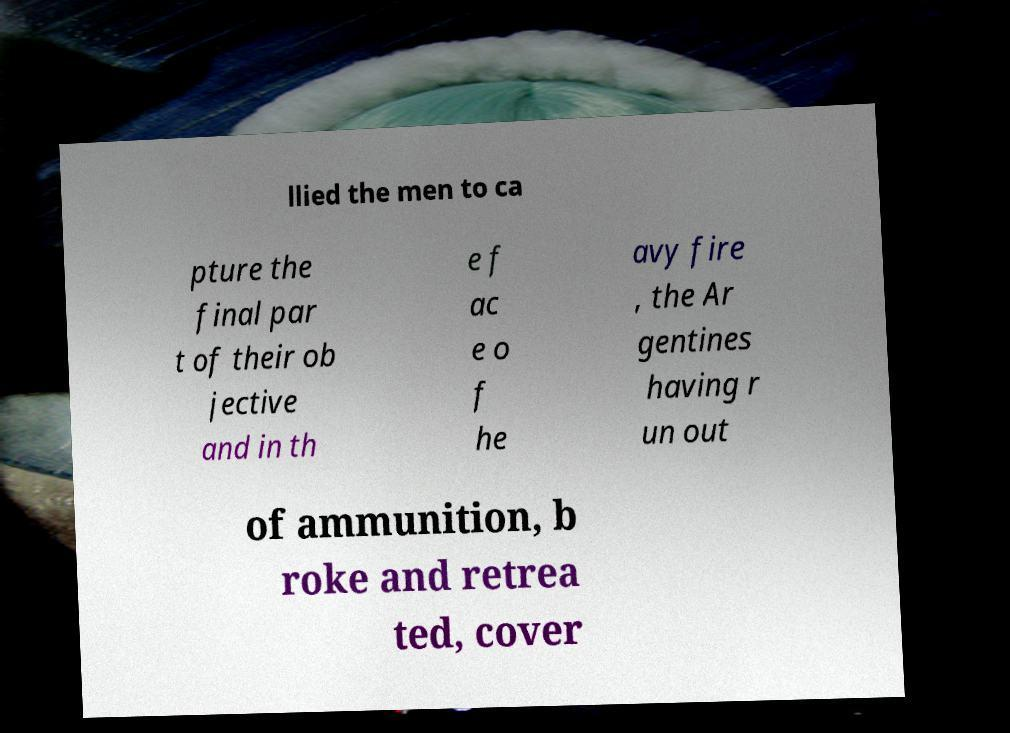There's text embedded in this image that I need extracted. Can you transcribe it verbatim? llied the men to ca pture the final par t of their ob jective and in th e f ac e o f he avy fire , the Ar gentines having r un out of ammunition, b roke and retrea ted, cover 